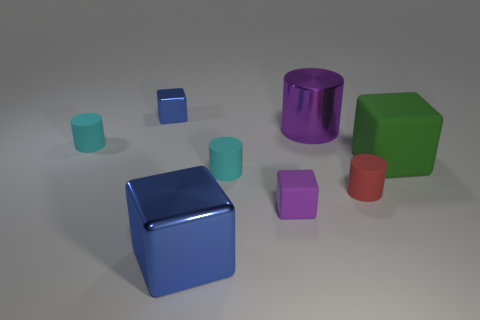Is the color of the tiny matte cylinder that is to the left of the tiny blue object the same as the block behind the green object?
Make the answer very short. No. What is the color of the shiny block to the left of the large blue cube?
Provide a short and direct response. Blue. There is a shiny block behind the green matte cube; does it have the same size as the green thing?
Provide a succinct answer. No. Are there fewer big blue shiny things than tiny purple cylinders?
Make the answer very short. No. What shape is the metal thing that is the same color as the small matte block?
Your answer should be very brief. Cylinder. What number of green rubber blocks are on the right side of the purple block?
Offer a very short reply. 1. Does the tiny purple object have the same shape as the red rubber thing?
Your answer should be very brief. No. How many blocks are both in front of the large green object and behind the purple shiny thing?
Offer a very short reply. 0. What number of objects are either big purple rubber spheres or small matte cylinders that are in front of the shiny cylinder?
Offer a very short reply. 3. Is the number of small red rubber things greater than the number of large metallic objects?
Your answer should be compact. No. 